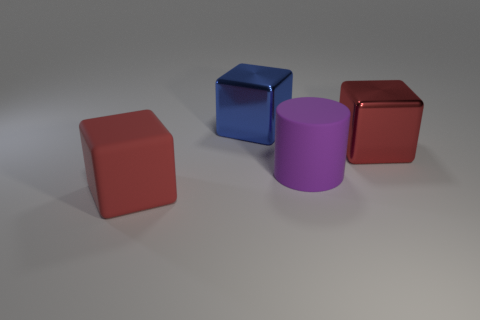Subtract all red blocks. How many blocks are left? 1 Subtract 1 blocks. How many blocks are left? 2 Add 2 large blue things. How many objects exist? 6 Subtract all cubes. How many objects are left? 1 Subtract all small green things. Subtract all shiny things. How many objects are left? 2 Add 2 large matte cubes. How many large matte cubes are left? 3 Add 2 large red metallic objects. How many large red metallic objects exist? 3 Subtract 0 gray balls. How many objects are left? 4 